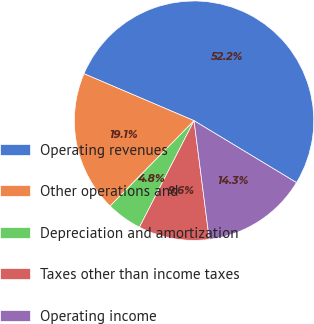Convert chart to OTSL. <chart><loc_0><loc_0><loc_500><loc_500><pie_chart><fcel>Operating revenues<fcel>Other operations and<fcel>Depreciation and amortization<fcel>Taxes other than income taxes<fcel>Operating income<nl><fcel>52.23%<fcel>19.05%<fcel>4.83%<fcel>9.57%<fcel>14.31%<nl></chart> 